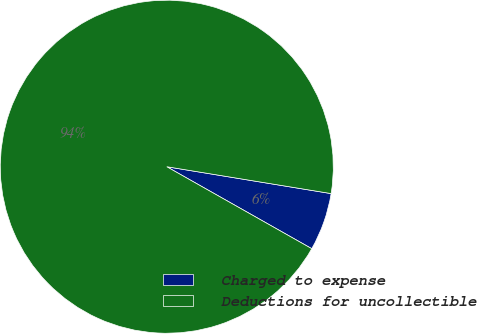Convert chart. <chart><loc_0><loc_0><loc_500><loc_500><pie_chart><fcel>Charged to expense<fcel>Deductions for uncollectible<nl><fcel>5.61%<fcel>94.39%<nl></chart> 